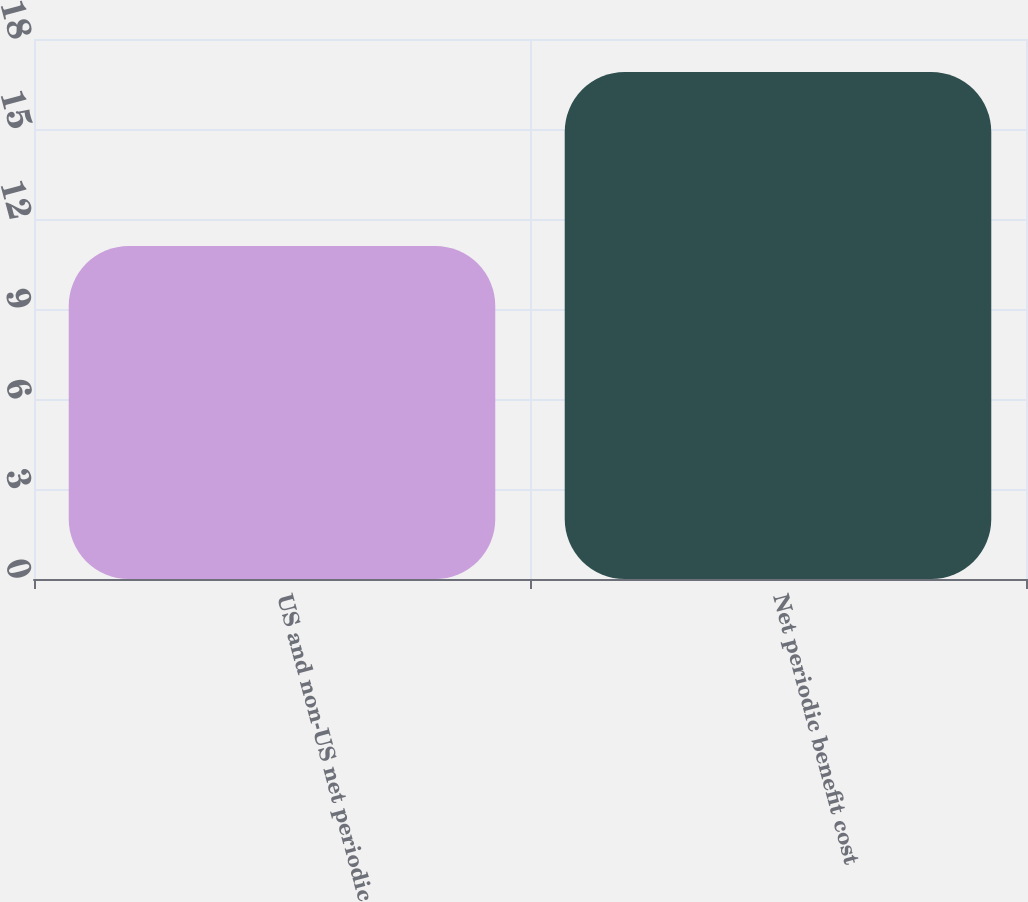<chart> <loc_0><loc_0><loc_500><loc_500><bar_chart><fcel>US and non-US net periodic<fcel>Net periodic benefit cost<nl><fcel>11.1<fcel>16.9<nl></chart> 